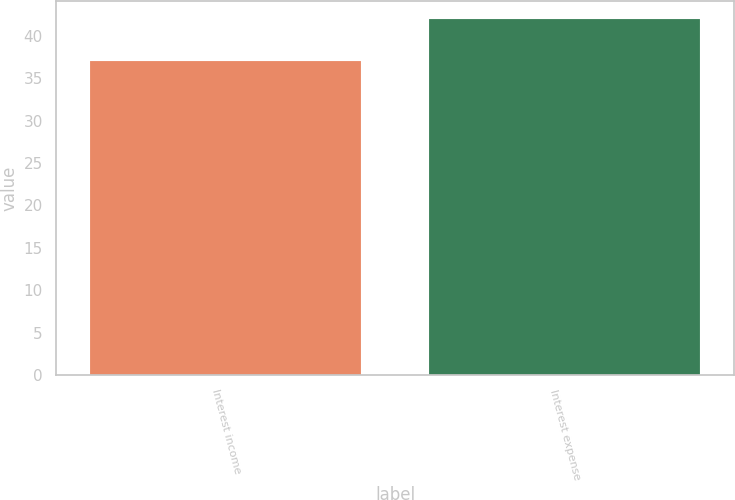<chart> <loc_0><loc_0><loc_500><loc_500><bar_chart><fcel>Interest income<fcel>Interest expense<nl><fcel>37<fcel>42<nl></chart> 